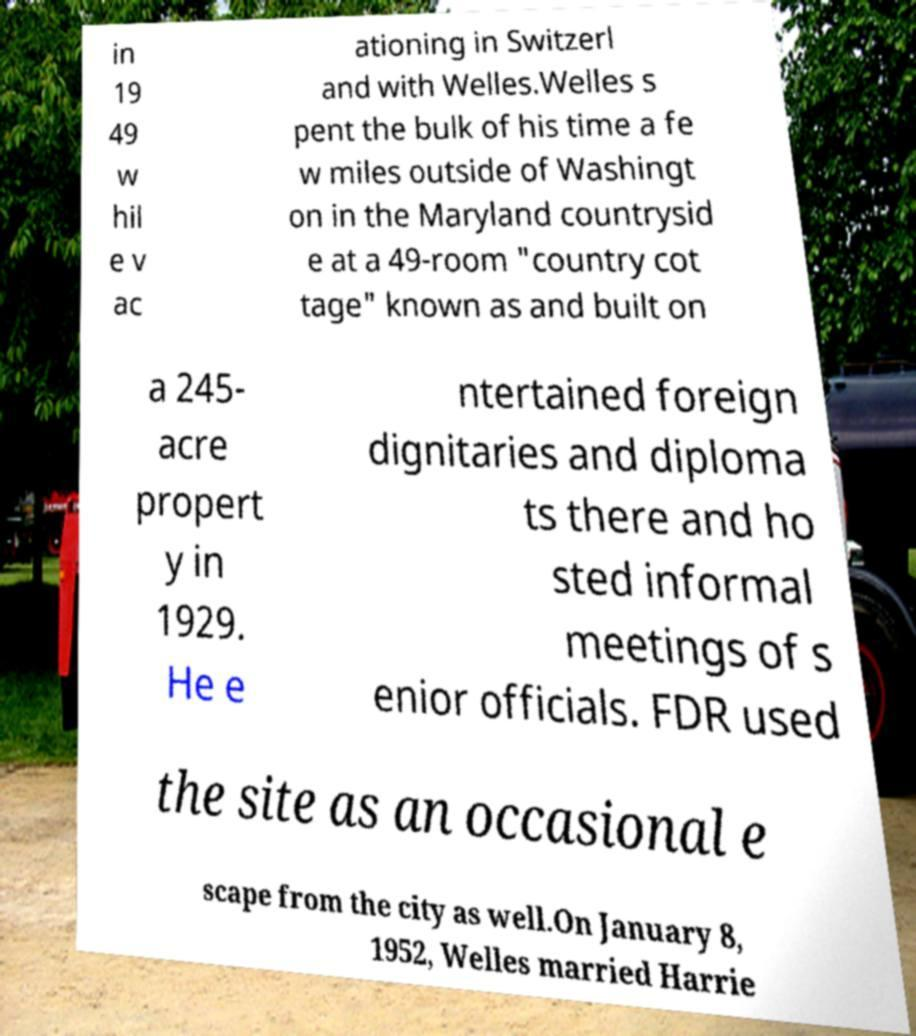Can you read and provide the text displayed in the image?This photo seems to have some interesting text. Can you extract and type it out for me? in 19 49 w hil e v ac ationing in Switzerl and with Welles.Welles s pent the bulk of his time a fe w miles outside of Washingt on in the Maryland countrysid e at a 49-room "country cot tage" known as and built on a 245- acre propert y in 1929. He e ntertained foreign dignitaries and diploma ts there and ho sted informal meetings of s enior officials. FDR used the site as an occasional e scape from the city as well.On January 8, 1952, Welles married Harrie 